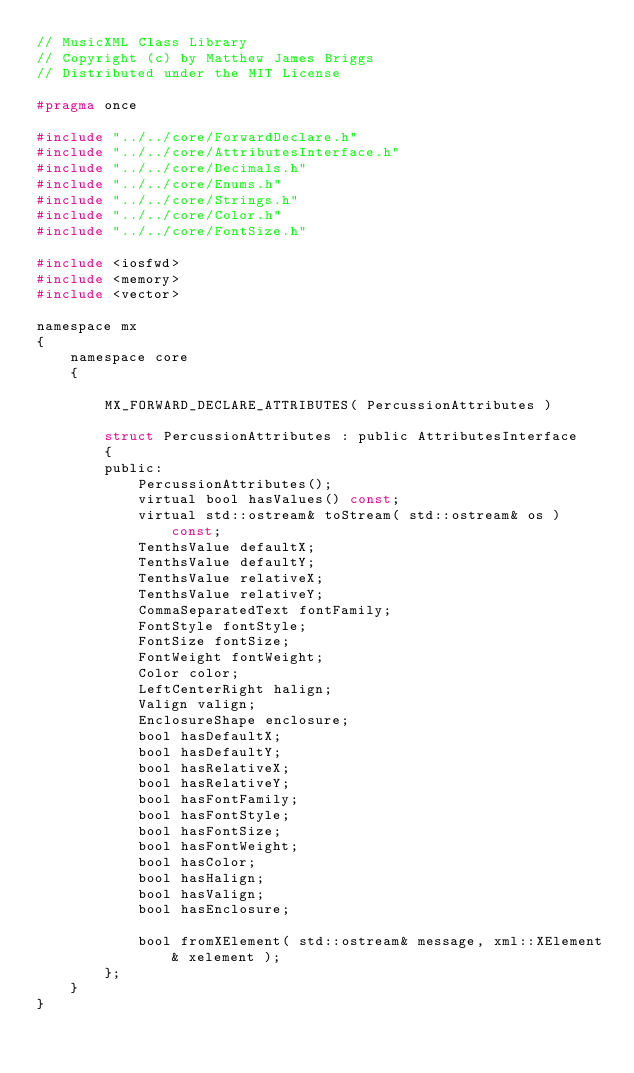Convert code to text. <code><loc_0><loc_0><loc_500><loc_500><_C_>// MusicXML Class Library
// Copyright (c) by Matthew James Briggs
// Distributed under the MIT License

#pragma once

#include "../../core/ForwardDeclare.h"
#include "../../core/AttributesInterface.h"
#include "../../core/Decimals.h"
#include "../../core/Enums.h"
#include "../../core/Strings.h"
#include "../../core/Color.h"
#include "../../core/FontSize.h"

#include <iosfwd>
#include <memory>
#include <vector>

namespace mx
{
    namespace core
    {

        MX_FORWARD_DECLARE_ATTRIBUTES( PercussionAttributes )

        struct PercussionAttributes : public AttributesInterface
        {
        public:
            PercussionAttributes();
            virtual bool hasValues() const;
            virtual std::ostream& toStream( std::ostream& os ) const;
            TenthsValue defaultX;
            TenthsValue defaultY;
            TenthsValue relativeX;
            TenthsValue relativeY;
            CommaSeparatedText fontFamily;
            FontStyle fontStyle;
            FontSize fontSize;
            FontWeight fontWeight;
            Color color;
            LeftCenterRight halign;
            Valign valign;
            EnclosureShape enclosure;
            bool hasDefaultX;
            bool hasDefaultY;
            bool hasRelativeX;
            bool hasRelativeY;
            bool hasFontFamily;
            bool hasFontStyle;
            bool hasFontSize;
            bool hasFontWeight;
            bool hasColor;
            bool hasHalign;
            bool hasValign;
            bool hasEnclosure;

            bool fromXElement( std::ostream& message, xml::XElement& xelement );
        };
    }
}
</code> 